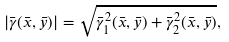<formula> <loc_0><loc_0><loc_500><loc_500>| \bar { \gamma } ( \bar { x } , \bar { y } ) | = \sqrt { \bar { \gamma } _ { 1 } ^ { 2 } ( \bar { x } , \bar { y } ) + \bar { \gamma } _ { 2 } ^ { 2 } ( \bar { x } , \bar { y } ) } ,</formula> 